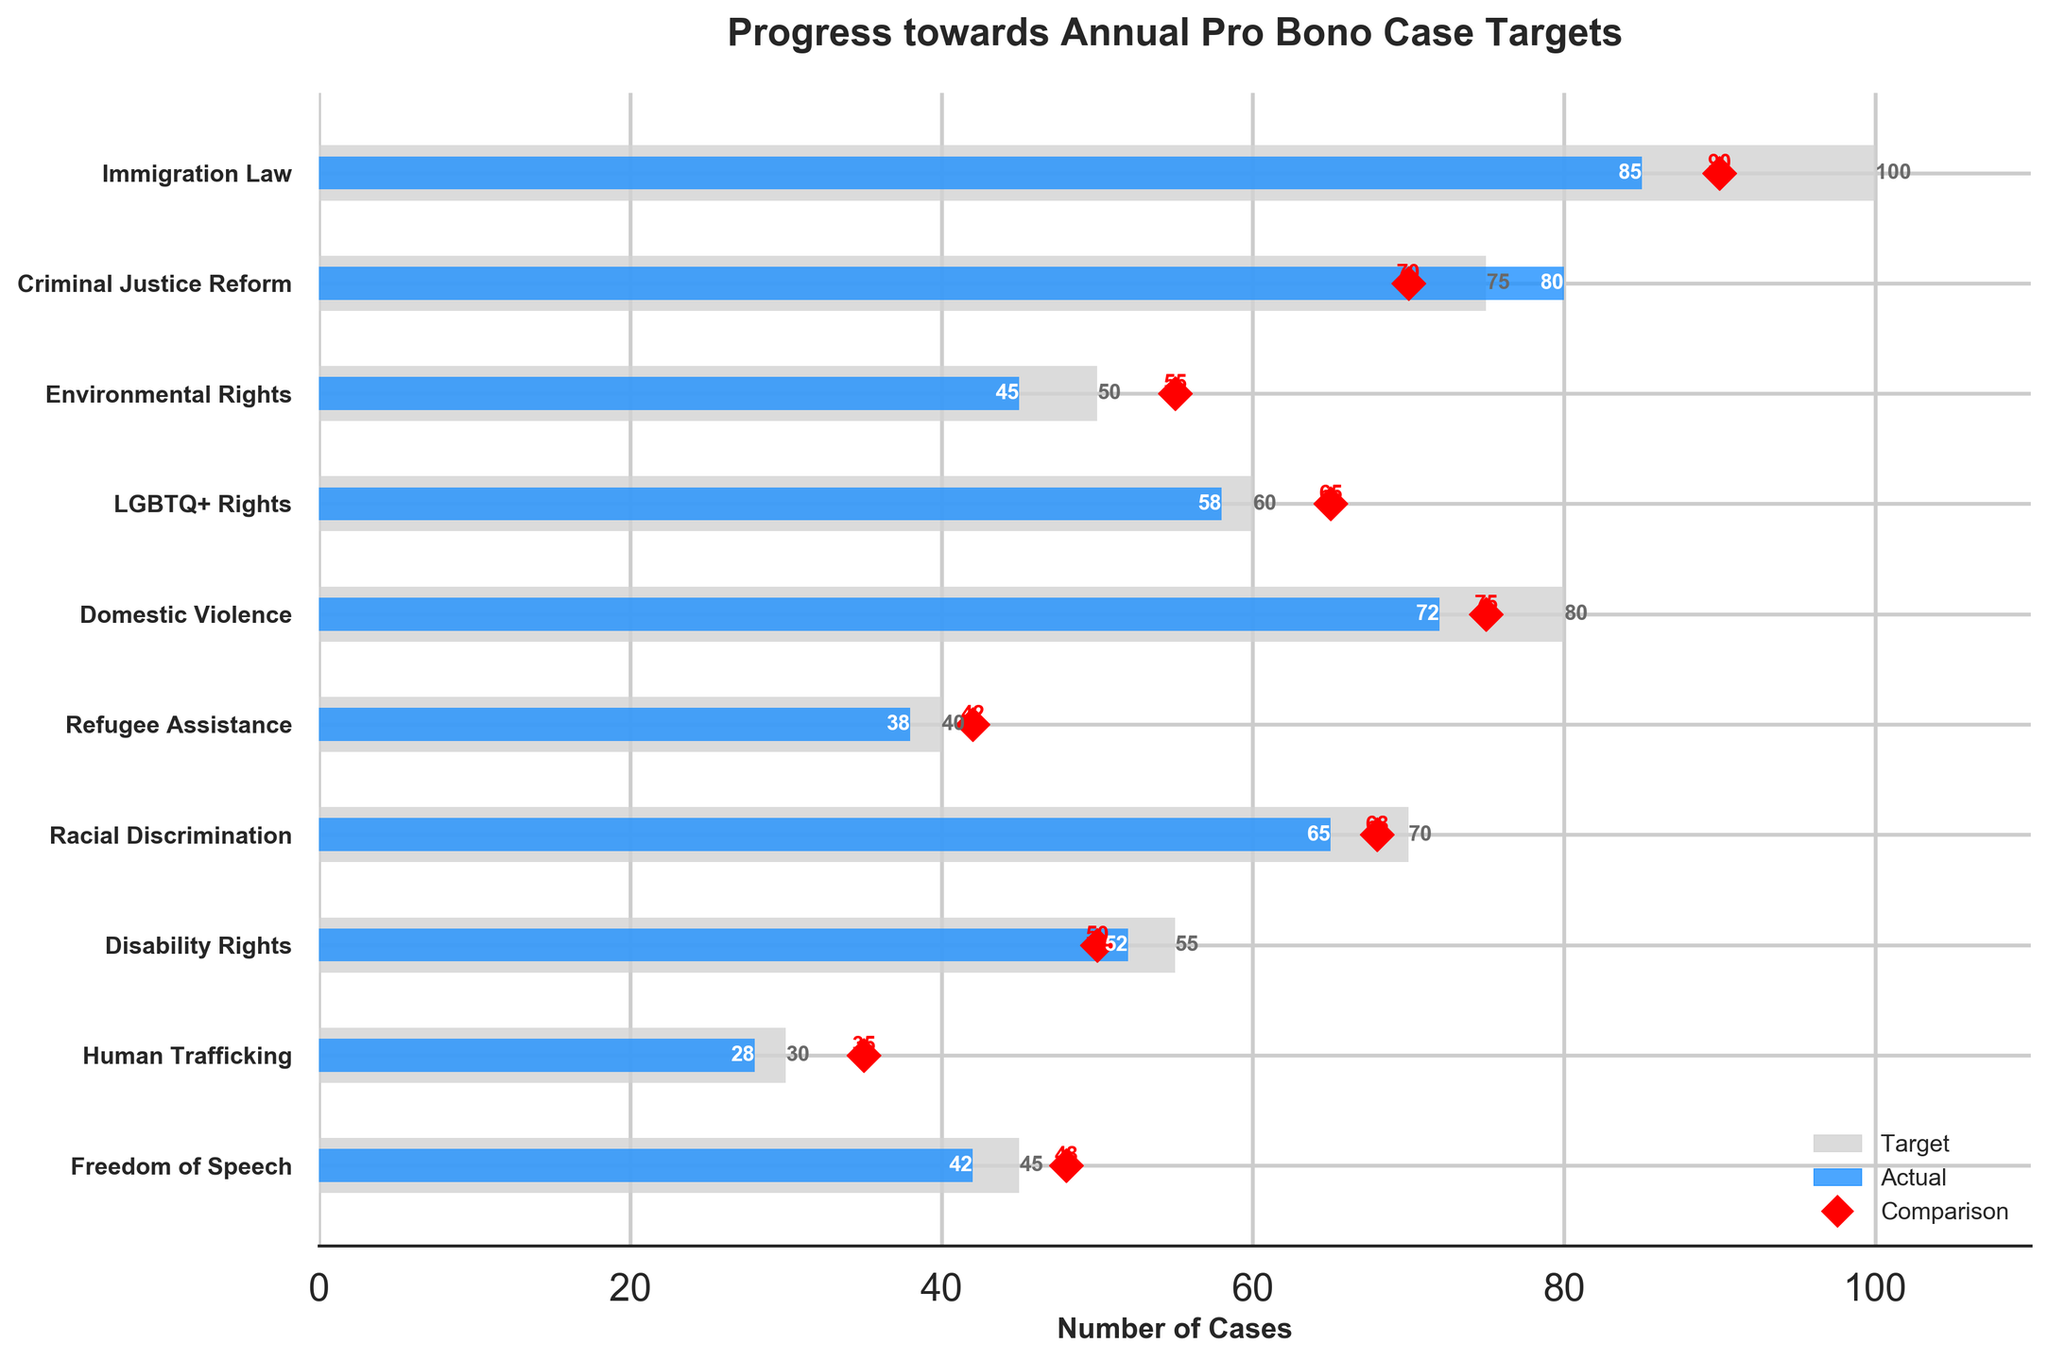What is the title of the figure? The title is prominently displayed at the top of the chart.
Answer: Progress towards Annual Pro Bono Case Targets Which legal area has the highest target? Observe the horizontal bars representing the targets. The longest bar corresponds to the highest target value.
Answer: Immigration Law How many legal areas achieved their target? Compare the blue bars (actuals) with the light grey bars (targets). Count the instances where the blue bar meets or exceeds the grey bar.
Answer: 1 Which legal area had the greatest discrepancy between actual and target values? Calculate the differences between actual and target values for each legal area and identify the largest difference.
Answer: Domestic Violence (80 - 72 = 8) What is the difference between the actual and target cases for Environmental Rights? Subtract the actual value from the target value for Environmental Rights.
Answer: 5 (50 - 45) How did the actual cases for LGBTQ+ Rights compare to the comparison value? Compare the blue bar (actual 58) with the red marker (comparison 65) for LGBTQ+ Rights.
Answer: Below Arrange the legal areas in descending order of actual cases. Order the categories by the length of the blue bars, from longest to shortest.
Answer: Criminal Justice Reform, Immigration Law, Domestic Violence, LGBTQ+ Rights, Racial Discrimination, Disability Rights, Environmental Rights, Freedom of Speech, Refugee Assistance, Human Trafficking What is the total number of target cases across all legal areas? Sum the target values of all categories.
Answer: 605 (100 + 75 + 50 + 60 + 80 + 40 + 70 + 55 + 30 + 45) Which legal area had the smallest actual number of cases? Identify the shortest blue bar representing the actual number of cases.
Answer: Human Trafficking 